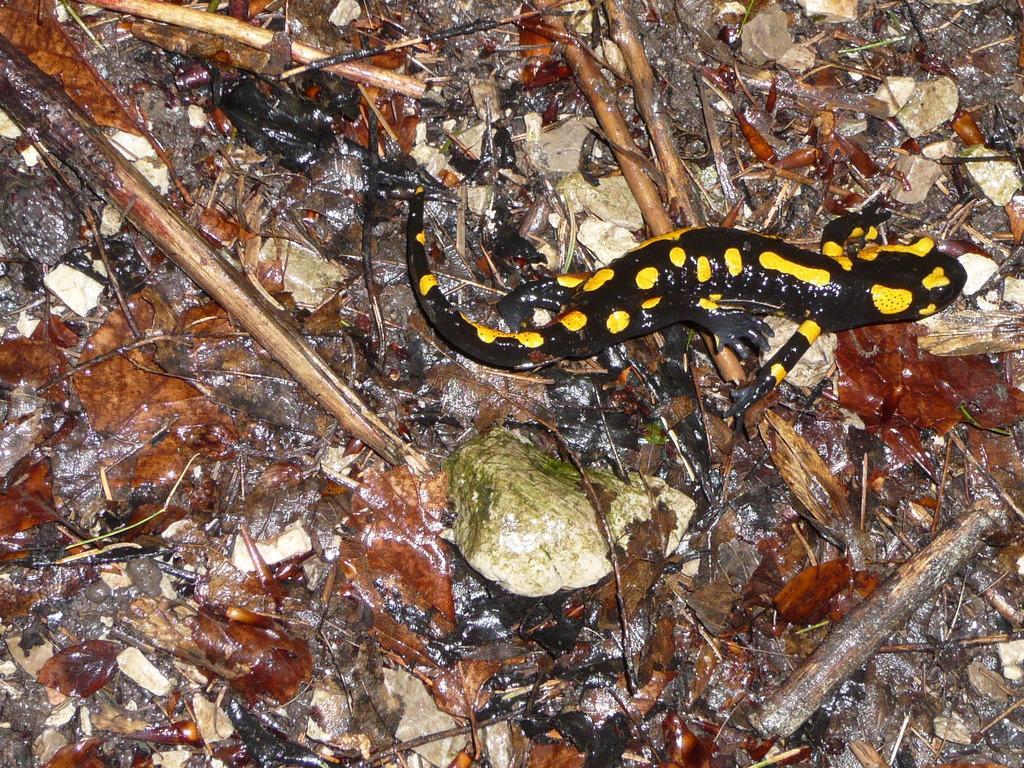In one or two sentences, can you explain what this image depicts? There is a lizard in black and yellow color combination on the ground on which, there are dry leaves, sticks and stones. 